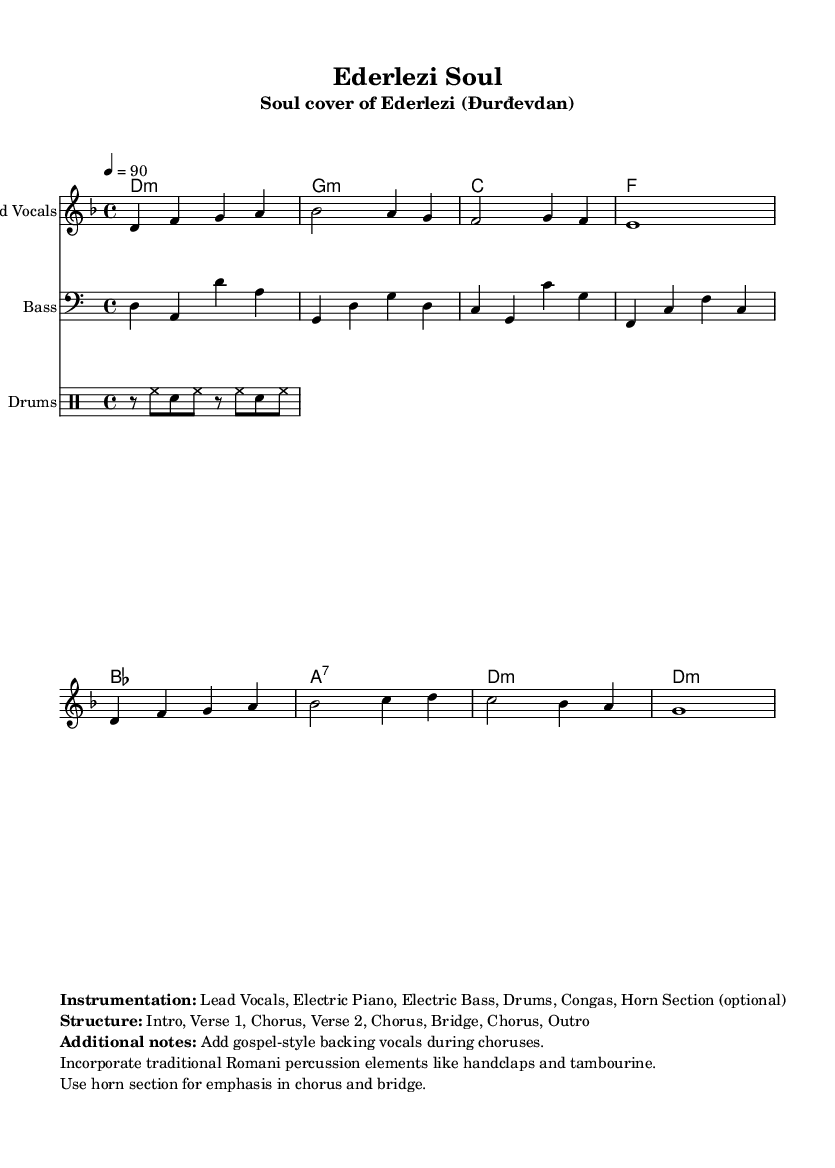What is the key signature of this music? The key signature indicated at the beginning of the score is D minor, which has one flat (B flat).
Answer: D minor What is the time signature of this piece? The time signature shown at the start of the score is 4/4, indicating that there are four beats per measure.
Answer: 4/4 What is the tempo marking for this music? The tempo marking indicates a speed of 90 beats per minute, denoted by "4 = 90".
Answer: 90 How many verses are there in the song structure? The structure outlines that there are two verses and additional sections, meaning there are two verses in total.
Answer: 2 What type of backing vocals are suggested during the choruses? The notes specify that gospel-style backing vocals are to be added during the choruses for richness in harmony.
Answer: Gospel-style What additional percussion elements are incorporated into the music? The notes mention the incorporation of traditional Romani percussion elements such as handclaps and tambourine to enhance the feel.
Answer: Handclaps and tambourine What instrumentation is listed for the performance of this piece? The markup specifies the instrumentation required, including Lead Vocals, Electric Piano, Electric Bass, Drums, Congas, and an optional Horn Section.
Answer: Lead Vocals, Electric Piano, Electric Bass, Drums, Congas, Horn Section 